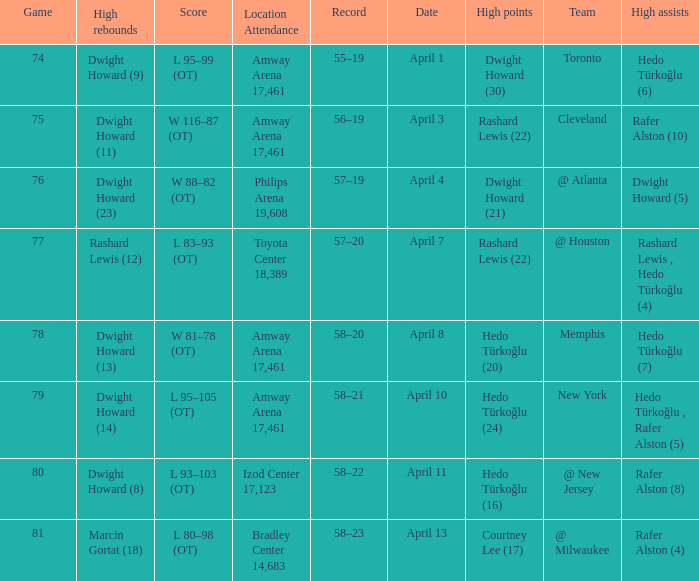Which player had the highest points in game 79? Hedo Türkoğlu (24). 